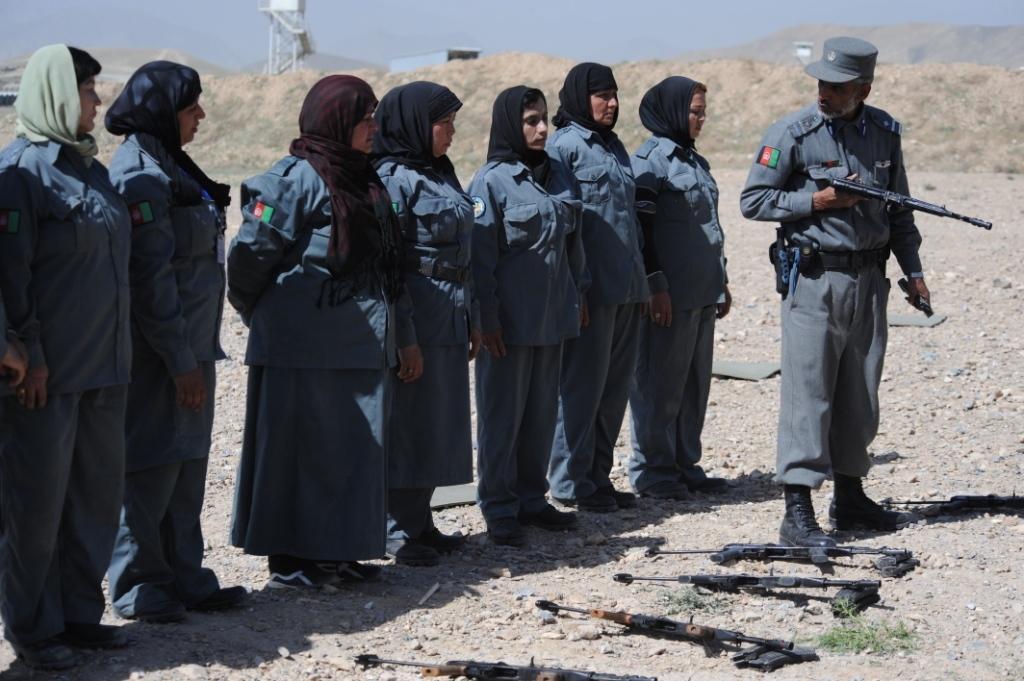Describe this image in one or two sentences. In this image we can see women and man standing on the ground. Of them man is holding gun in the hands. In the background we can see tower, hills, sky, sheds and guns on the ground. 